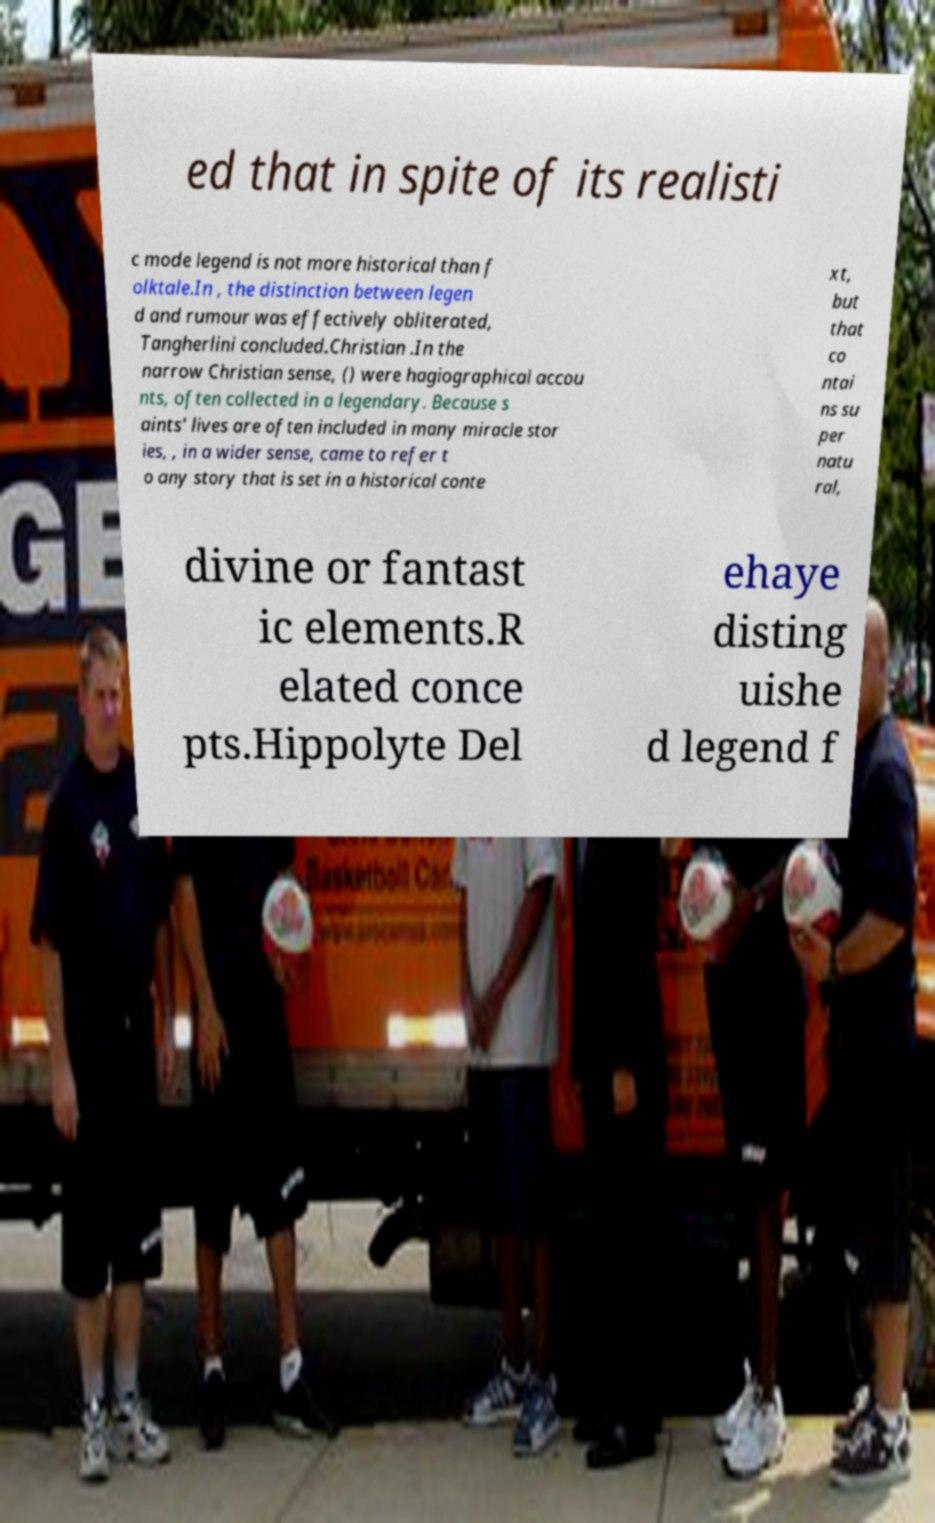Please identify and transcribe the text found in this image. ed that in spite of its realisti c mode legend is not more historical than f olktale.In , the distinction between legen d and rumour was effectively obliterated, Tangherlini concluded.Christian .In the narrow Christian sense, () were hagiographical accou nts, often collected in a legendary. Because s aints' lives are often included in many miracle stor ies, , in a wider sense, came to refer t o any story that is set in a historical conte xt, but that co ntai ns su per natu ral, divine or fantast ic elements.R elated conce pts.Hippolyte Del ehaye disting uishe d legend f 